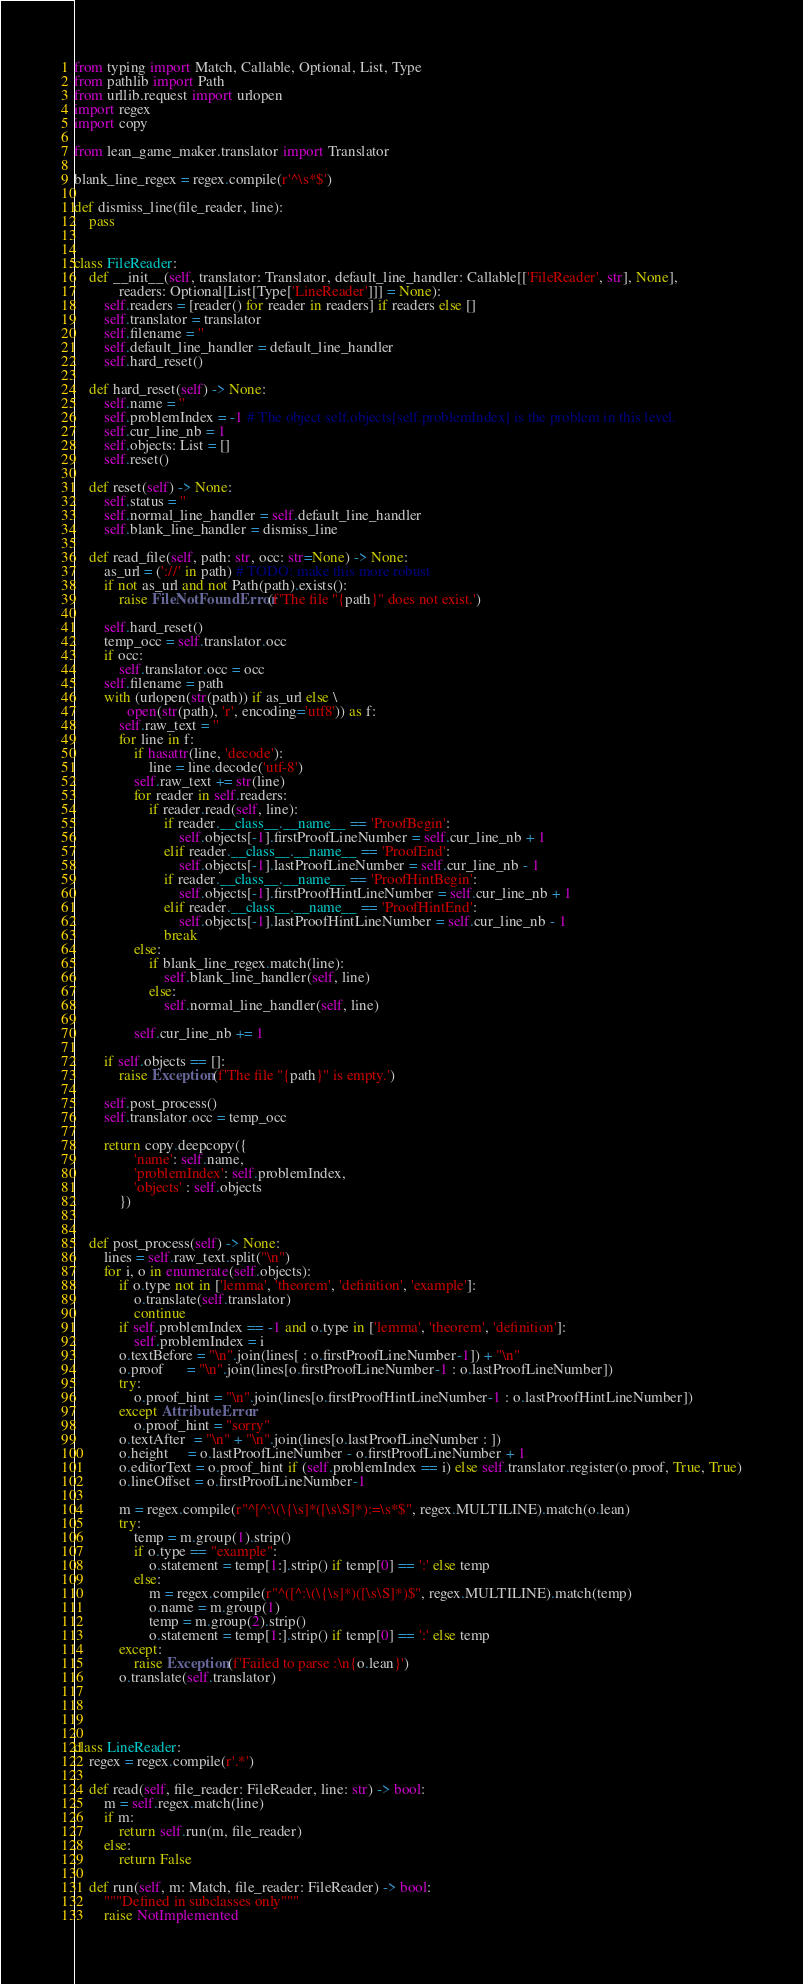Convert code to text. <code><loc_0><loc_0><loc_500><loc_500><_Python_>from typing import Match, Callable, Optional, List, Type
from pathlib import Path
from urllib.request import urlopen
import regex
import copy

from lean_game_maker.translator import Translator

blank_line_regex = regex.compile(r'^\s*$')

def dismiss_line(file_reader, line):
    pass


class FileReader:
    def __init__(self, translator: Translator, default_line_handler: Callable[['FileReader', str], None],
            readers: Optional[List[Type['LineReader']]] = None):
        self.readers = [reader() for reader in readers] if readers else []
        self.translator = translator
        self.filename = ''
        self.default_line_handler = default_line_handler
        self.hard_reset()

    def hard_reset(self) -> None:
        self.name = ''
        self.problemIndex = -1 # The object self.objects[self.problemIndex] is the problem in this level.
        self.cur_line_nb = 1
        self.objects: List = []
        self.reset()

    def reset(self) -> None:
        self.status = ''
        self.normal_line_handler = self.default_line_handler
        self.blank_line_handler = dismiss_line

    def read_file(self, path: str, occ: str=None) -> None:
        as_url = ('://' in path) # TODO: make this more robust
        if not as_url and not Path(path).exists():
            raise FileNotFoundError(f'The file "{path}" does not exist.')

        self.hard_reset()
        temp_occ = self.translator.occ
        if occ:
            self.translator.occ = occ
        self.filename = path
        with (urlopen(str(path)) if as_url else \
              open(str(path), 'r', encoding='utf8')) as f:
            self.raw_text = ''
            for line in f:
                if hasattr(line, 'decode'):
                    line = line.decode('utf-8')
                self.raw_text += str(line)
                for reader in self.readers:
                    if reader.read(self, line):
                        if reader.__class__.__name__ == 'ProofBegin':
                            self.objects[-1].firstProofLineNumber = self.cur_line_nb + 1
                        elif reader.__class__.__name__ == 'ProofEnd':
                            self.objects[-1].lastProofLineNumber = self.cur_line_nb - 1
                        if reader.__class__.__name__ == 'ProofHintBegin':
                            self.objects[-1].firstProofHintLineNumber = self.cur_line_nb + 1
                        elif reader.__class__.__name__ == 'ProofHintEnd':
                            self.objects[-1].lastProofHintLineNumber = self.cur_line_nb - 1
                        break
                else:
                    if blank_line_regex.match(line):
                        self.blank_line_handler(self, line)
                    else:
                        self.normal_line_handler(self, line)

                self.cur_line_nb += 1

        if self.objects == []:
            raise Exception(f'The file "{path}" is empty.')

        self.post_process()
        self.translator.occ = temp_occ
 
        return copy.deepcopy({
                'name': self.name, 
                'problemIndex': self.problemIndex, 
                'objects' : self.objects
            })


    def post_process(self) -> None:
        lines = self.raw_text.split("\n")
        for i, o in enumerate(self.objects):
            if o.type not in ['lemma', 'theorem', 'definition', 'example']:
                o.translate(self.translator)
                continue
            if self.problemIndex == -1 and o.type in ['lemma', 'theorem', 'definition']:
                self.problemIndex = i
            o.textBefore = "\n".join(lines[ : o.firstProofLineNumber-1]) + "\n"
            o.proof      = "\n".join(lines[o.firstProofLineNumber-1 : o.lastProofLineNumber])
            try:
                o.proof_hint = "\n".join(lines[o.firstProofHintLineNumber-1 : o.lastProofHintLineNumber])
            except AttributeError:
                o.proof_hint = "sorry"
            o.textAfter  = "\n" + "\n".join(lines[o.lastProofLineNumber : ])
            o.height     = o.lastProofLineNumber - o.firstProofLineNumber + 1
            o.editorText = o.proof_hint if (self.problemIndex == i) else self.translator.register(o.proof, True, True)
            o.lineOffset = o.firstProofLineNumber-1

            m = regex.compile(r"^[^:\(\{\s]*([\s\S]*):=\s*$", regex.MULTILINE).match(o.lean)
            try:
                temp = m.group(1).strip()
                if o.type == "example":
                    o.statement = temp[1:].strip() if temp[0] == ':' else temp
                else:
                    m = regex.compile(r"^([^:\(\{\s]*)([\s\S]*)$", regex.MULTILINE).match(temp)
                    o.name = m.group(1)
                    temp = m.group(2).strip()
                    o.statement = temp[1:].strip() if temp[0] == ':' else temp
            except:
                raise Exception(f'Failed to parse :\n{o.lean}')
            o.translate(self.translator)




class LineReader:
    regex = regex.compile(r'.*')

    def read(self, file_reader: FileReader, line: str) -> bool:
        m = self.regex.match(line)
        if m:
            return self.run(m, file_reader)
        else:
            return False

    def run(self, m: Match, file_reader: FileReader) -> bool:
        """Defined in subclasses only"""
        raise NotImplemented
</code> 